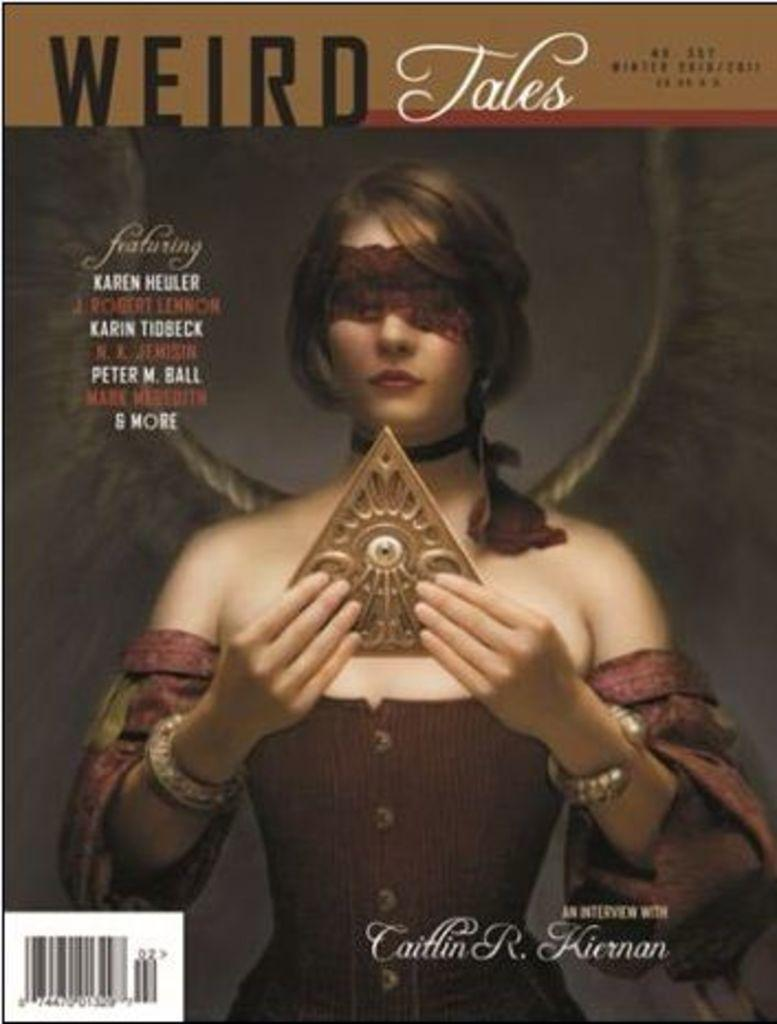<image>
Share a concise interpretation of the image provided. A Weird Tales magazine featuring Karen Heuler and others 